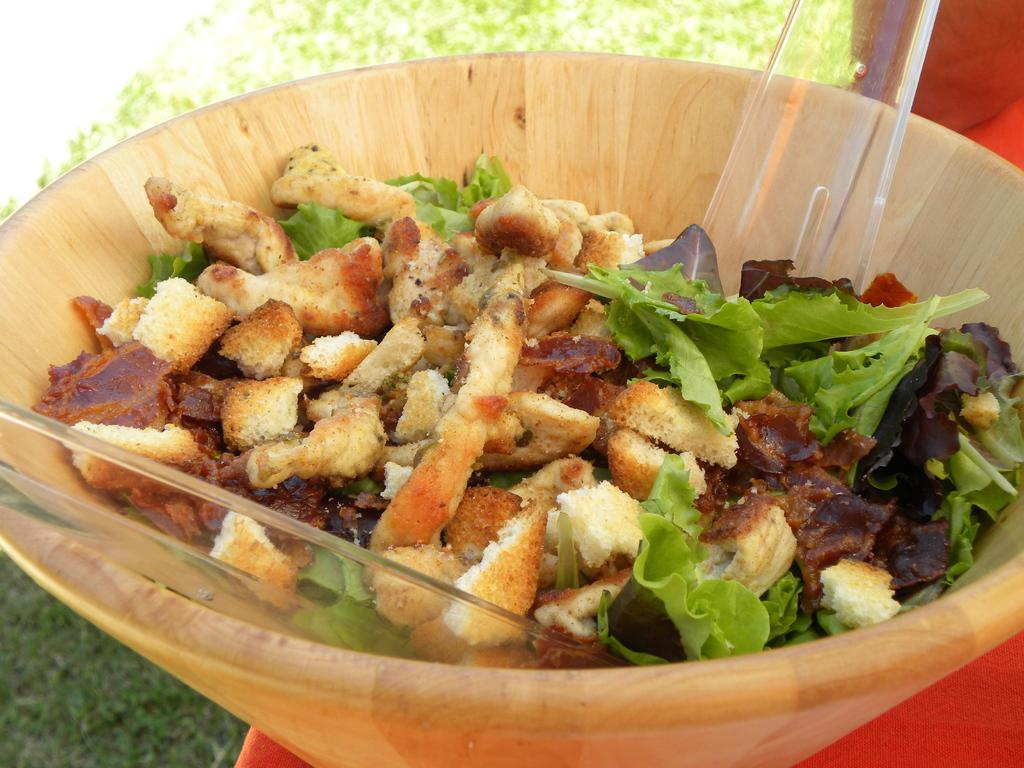What type of bowl is in the image? There is a wooden bowl in the image. What is inside the wooden bowl? Cabbage is present in the wooden bowl. What utensil is in the wooden bowl? There is a spoon in the wooden bowl. Where is the wooden bowl located? The wooden bowl is on a white table. What type of vegetation is visible in the image? Grass is visible in the bottom left corner of the image. What type of book is being read by the cabbage in the image? There is no book or cabbage reading a book in the image. 